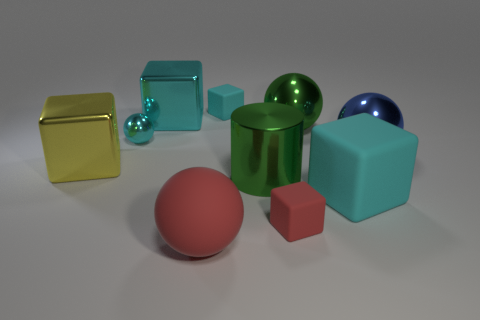There is a cube that is to the left of the metallic cylinder and on the right side of the big red matte sphere; what is it made of?
Ensure brevity in your answer.  Rubber. How big is the red thing on the right side of the tiny block that is behind the green metallic thing that is in front of the blue metallic ball?
Provide a succinct answer. Small. Are there more large green objects than red metal blocks?
Offer a terse response. Yes. Is the sphere that is in front of the yellow shiny thing made of the same material as the blue ball?
Your response must be concise. No. Is the number of cyan shiny blocks less than the number of spheres?
Keep it short and to the point. Yes. There is a big cyan rubber object that is to the right of the tiny cube that is behind the large green metallic cylinder; are there any blue metal things that are to the right of it?
Offer a terse response. Yes. There is a cyan matte thing behind the small cyan metal sphere; is its shape the same as the blue metallic thing?
Give a very brief answer. No. Is the number of cyan objects behind the big green cylinder greater than the number of cyan matte things?
Offer a terse response. Yes. There is a big matte object that is right of the big red matte sphere; is it the same color as the rubber ball?
Your response must be concise. No. Is there anything else of the same color as the big metal cylinder?
Keep it short and to the point. Yes. 